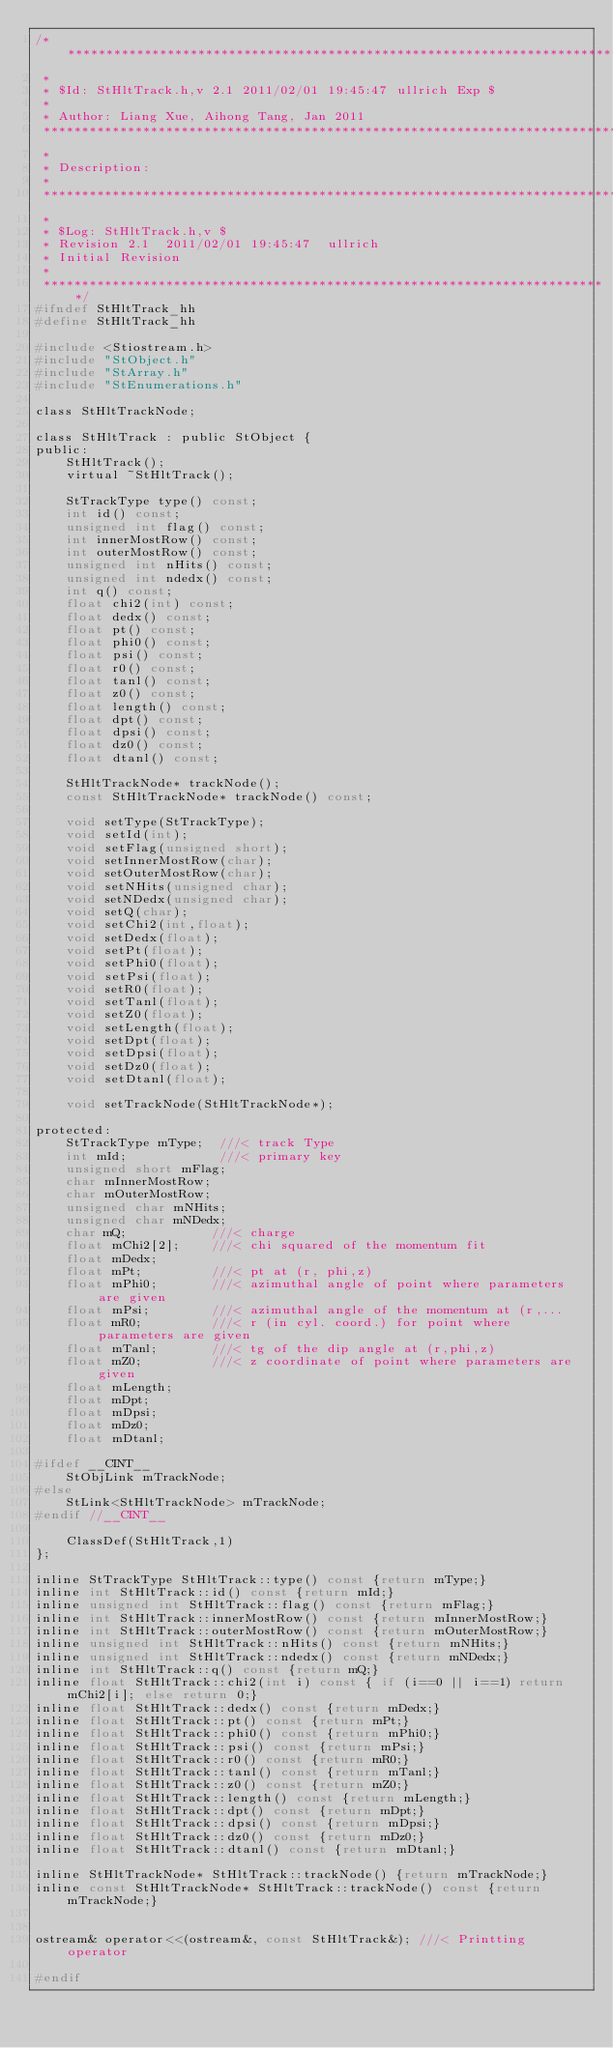<code> <loc_0><loc_0><loc_500><loc_500><_C_>/***************************************************************************
 *
 * $Id: StHltTrack.h,v 2.1 2011/02/01 19:45:47 ullrich Exp $
 *
 * Author: Liang Xue, Aihong Tang, Jan 2011
 ***************************************************************************
 *
 * Description:
 *
 ***************************************************************************
 *
 * $Log: StHltTrack.h,v $
 * Revision 2.1  2011/02/01 19:45:47  ullrich
 * Initial Revision
 *
 **************************************************************************/
#ifndef StHltTrack_hh
#define StHltTrack_hh

#include <Stiostream.h>
#include "StObject.h"
#include "StArray.h"
#include "StEnumerations.h"

class StHltTrackNode;

class StHltTrack : public StObject {
public:
    StHltTrack();
    virtual ~StHltTrack();
    
    StTrackType type() const;
    int id() const;
    unsigned int flag() const;
    int innerMostRow() const;
    int outerMostRow() const;
    unsigned int nHits() const;
    unsigned int ndedx() const;
    int q() const;
    float chi2(int) const;
    float dedx() const;
    float pt() const;
    float phi0() const;
    float psi() const;
    float r0() const;
    float tanl() const;
    float z0() const;
    float length() const;
    float dpt() const;
    float dpsi() const;
    float dz0() const;
    float dtanl() const;
    
    StHltTrackNode* trackNode();
    const StHltTrackNode* trackNode() const;
    
    void setType(StTrackType);
    void setId(int);
    void setFlag(unsigned short);
    void setInnerMostRow(char);
    void setOuterMostRow(char);
    void setNHits(unsigned char);
    void setNDedx(unsigned char);
    void setQ(char);
    void setChi2(int,float);
    void setDedx(float);
    void setPt(float);
    void setPhi0(float);
    void setPsi(float);
    void setR0(float);
    void setTanl(float);
    void setZ0(float);
    void setLength(float);
    void setDpt(float);
    void setDpsi(float);
    void setDz0(float);
    void setDtanl(float);
    
    void setTrackNode(StHltTrackNode*);
    
protected:
    StTrackType mType;  ///< track Type
    int mId;            ///< primary key
    unsigned short mFlag;
    char mInnerMostRow;
    char mOuterMostRow;
    unsigned char mNHits; 
    unsigned char mNDedx; 
    char mQ;           ///< charge
    float mChi2[2];    ///< chi squared of the momentum fit
    float mDedx;
    float mPt;         ///< pt at (r, phi,z)
    float mPhi0;       ///< azimuthal angle of point where parameters are given
    float mPsi;        ///< azimuthal angle of the momentum at (r,...
    float mR0;         ///< r (in cyl. coord.) for point where parameters are given
    float mTanl;       ///< tg of the dip angle at (r,phi,z)
    float mZ0;         ///< z coordinate of point where parameters are given
    float mLength;
    float mDpt;
    float mDpsi;
    float mDz0;
    float mDtanl;
    
#ifdef __CINT__
    StObjLink mTrackNode;
#else
    StLink<StHltTrackNode> mTrackNode;
#endif //__CINT__
    
    ClassDef(StHltTrack,1)
};

inline StTrackType StHltTrack::type() const {return mType;}
inline int StHltTrack::id() const {return mId;}
inline unsigned int StHltTrack::flag() const {return mFlag;}
inline int StHltTrack::innerMostRow() const {return mInnerMostRow;}
inline int StHltTrack::outerMostRow() const {return mOuterMostRow;}
inline unsigned int StHltTrack::nHits() const {return mNHits;}
inline unsigned int StHltTrack::ndedx() const {return mNDedx;}
inline int StHltTrack::q() const {return mQ;}
inline float StHltTrack::chi2(int i) const { if (i==0 || i==1) return mChi2[i]; else return 0;}
inline float StHltTrack::dedx() const {return mDedx;}
inline float StHltTrack::pt() const {return mPt;}
inline float StHltTrack::phi0() const {return mPhi0;}
inline float StHltTrack::psi() const {return mPsi;}
inline float StHltTrack::r0() const {return mR0;}
inline float StHltTrack::tanl() const {return mTanl;}
inline float StHltTrack::z0() const {return mZ0;}
inline float StHltTrack::length() const {return mLength;}
inline float StHltTrack::dpt() const {return mDpt;}
inline float StHltTrack::dpsi() const {return mDpsi;}
inline float StHltTrack::dz0() const {return mDz0;}
inline float StHltTrack::dtanl() const {return mDtanl;}

inline StHltTrackNode* StHltTrack::trackNode() {return mTrackNode;}
inline const StHltTrackNode* StHltTrack::trackNode() const {return mTrackNode;}


ostream& operator<<(ostream&, const StHltTrack&); ///< Printting operator

#endif







</code> 